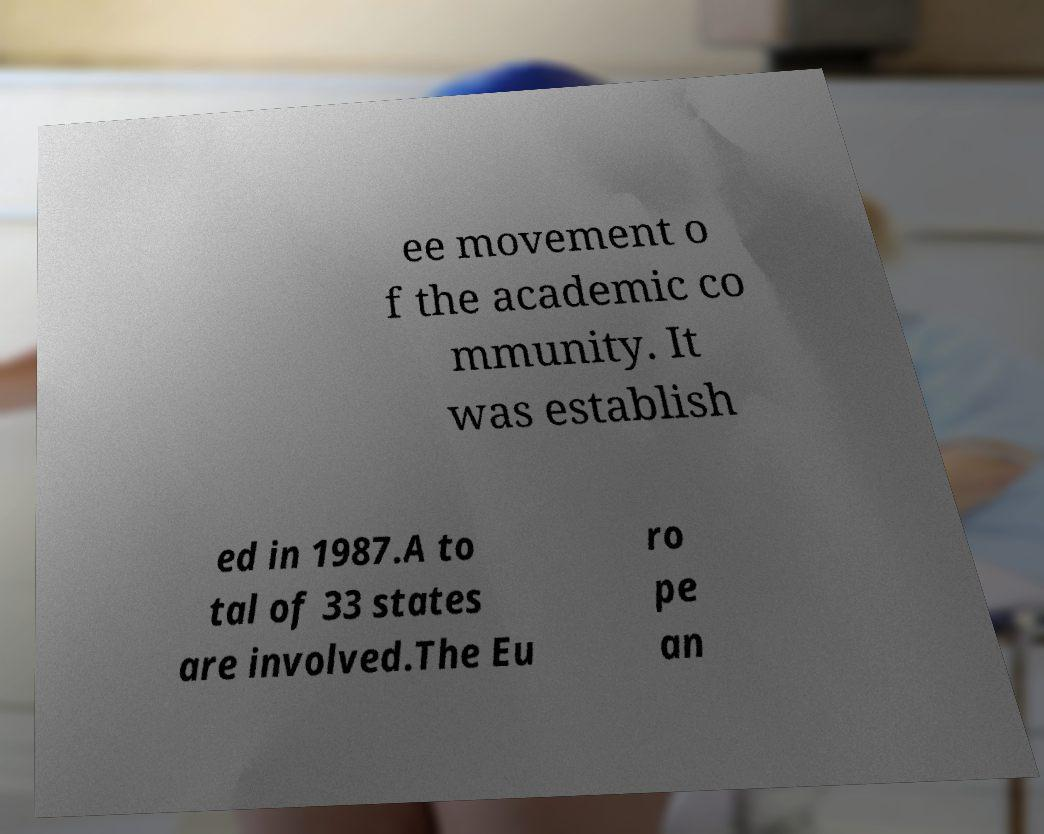There's text embedded in this image that I need extracted. Can you transcribe it verbatim? ee movement o f the academic co mmunity. It was establish ed in 1987.A to tal of 33 states are involved.The Eu ro pe an 